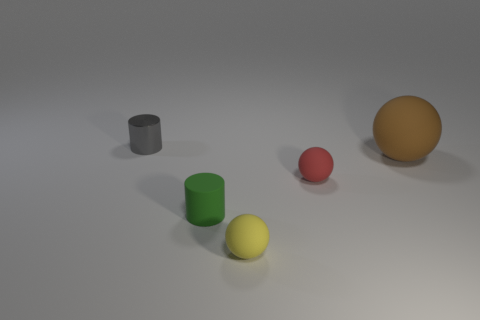How many objects are there in total within this scene? In this scene, there are four objects in total: a gray cylindrical object, a green cylinder, a red ball, and a yellow spherical object that appears matte. 